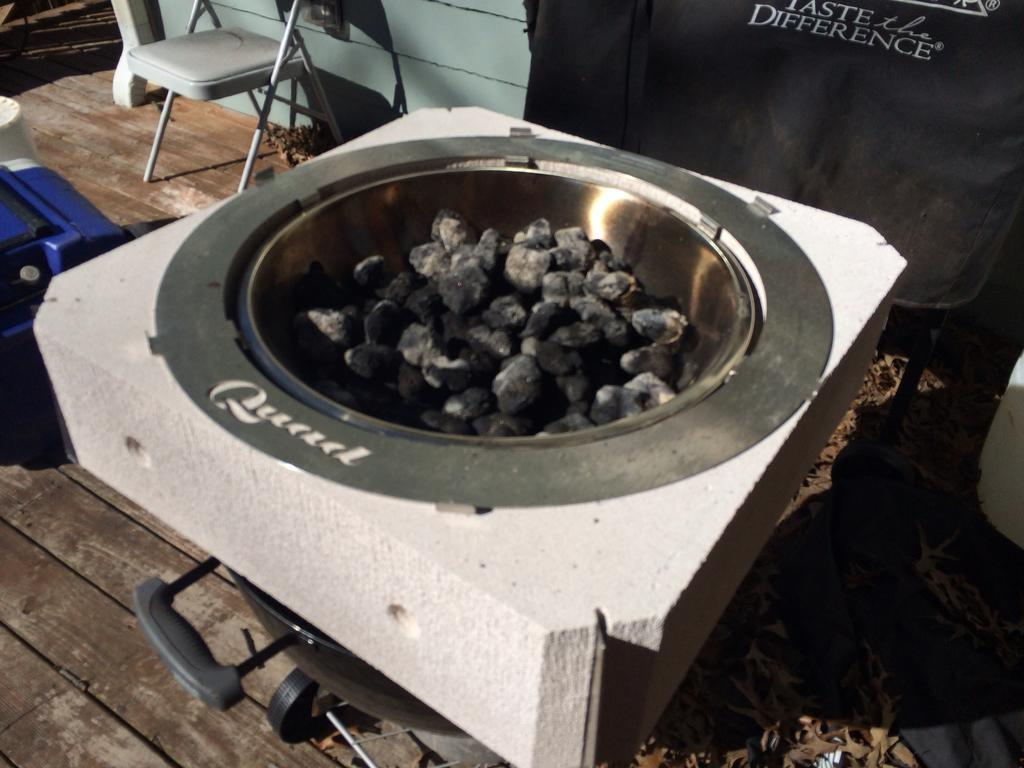What type of cooking pot is in the image? There is a Dutch oven in the image. What type of furniture is in the image? There is a chair in the image. What can be seen on the wooden surface in the image? There are objects on a wooden surface in the image. What is visible in the background of the image? There is a wall in the background of the image. What type of reward is the army giving out in the image? There is no army or reward present in the image. What type of ground is visible in the image? There is no ground visible in the image; it appears to be an indoor setting. 